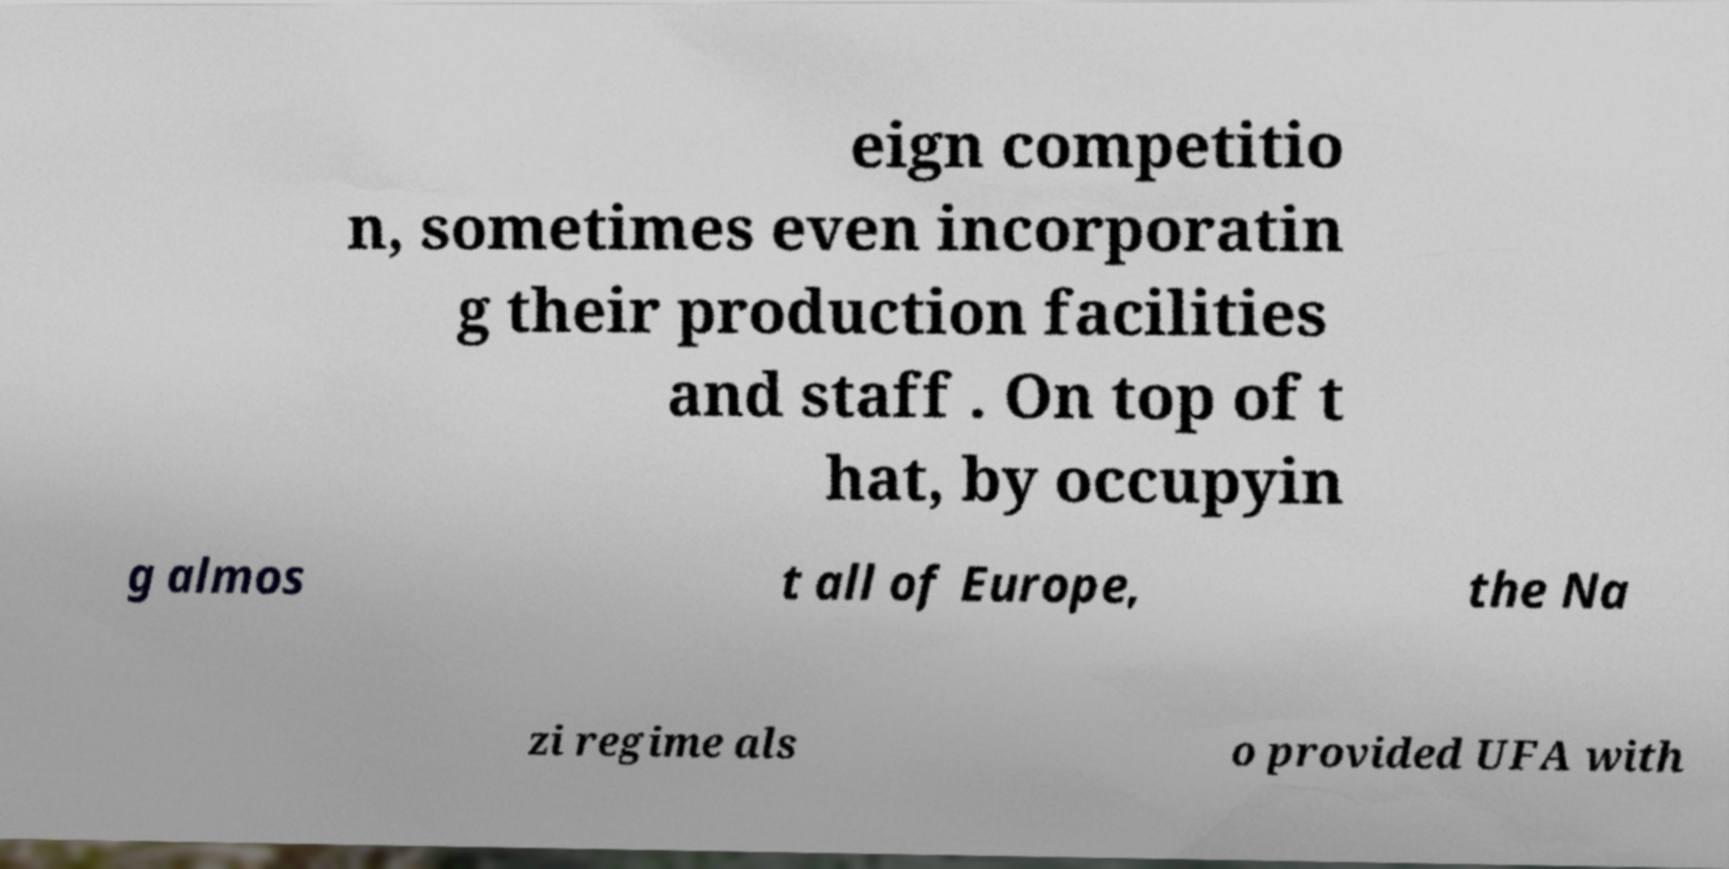Could you extract and type out the text from this image? eign competitio n, sometimes even incorporatin g their production facilities and staff . On top of t hat, by occupyin g almos t all of Europe, the Na zi regime als o provided UFA with 